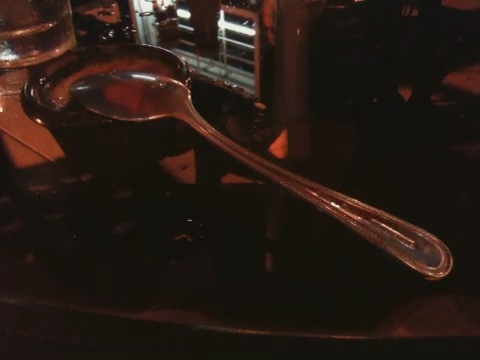Describe the objects in this image and their specific colors. I can see dining table in black, maroon, and brown tones, bowl in maroon, black, gray, and brown tones, spoon in maroon, black, and brown tones, bottle in maroon, black, and brown tones, and cup in maroon, black, and brown tones in this image. 